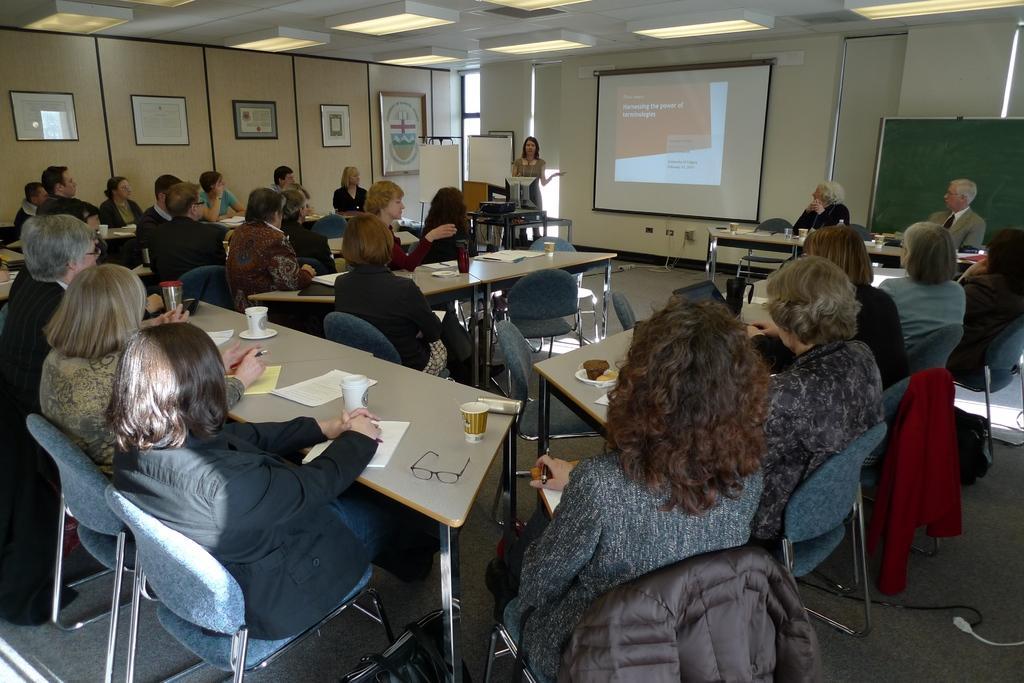Describe this image in one or two sentences. In this image I can see people where one is standing and rest all are sitting on chairs. I can also see few tables and on these tables I can see few cups, papers and a specs. In the background I can see a projector screen and here I can see few frames on this wall. I can also see few jackets over here. 